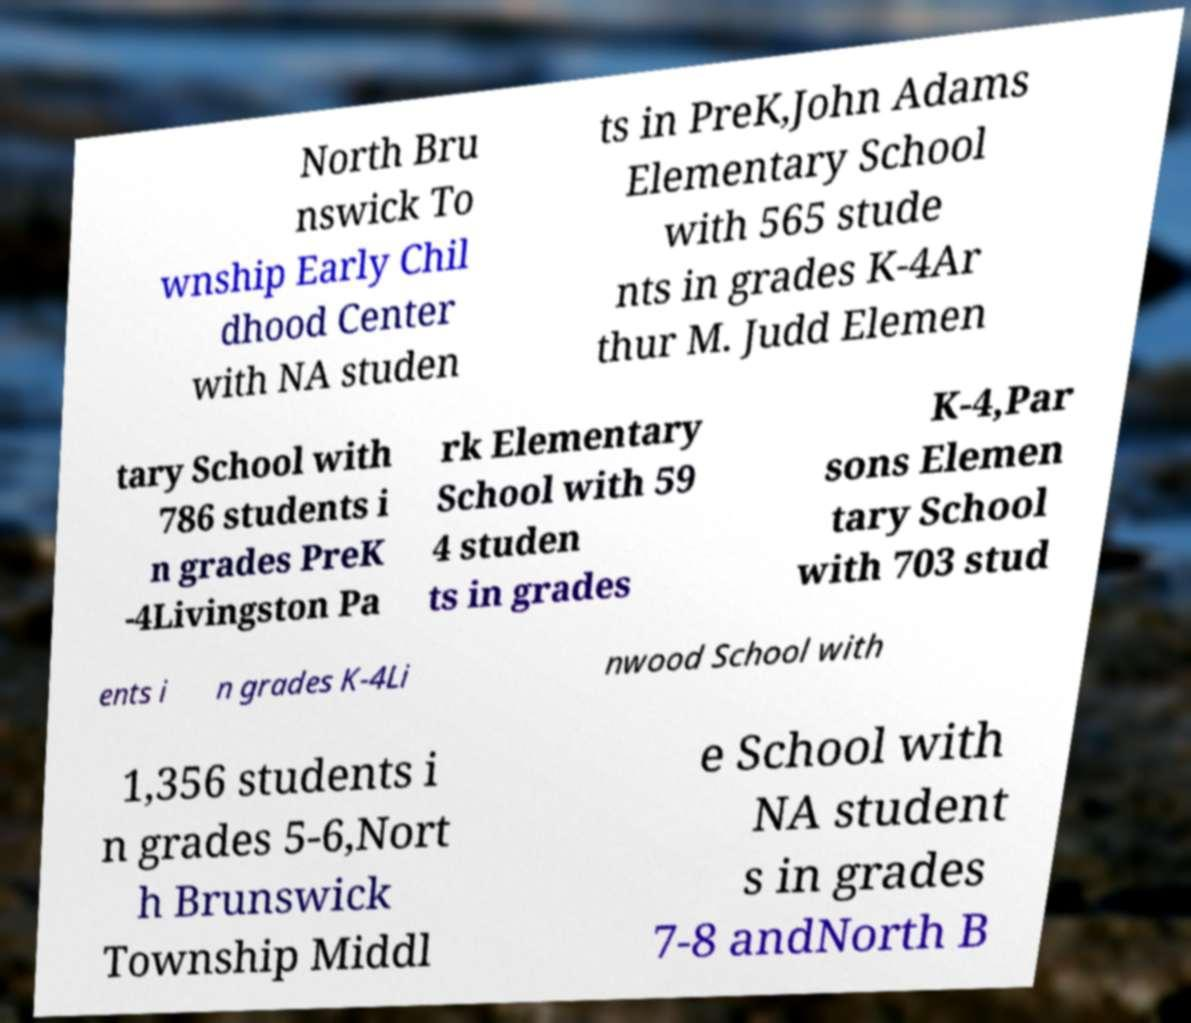Please read and relay the text visible in this image. What does it say? North Bru nswick To wnship Early Chil dhood Center with NA studen ts in PreK,John Adams Elementary School with 565 stude nts in grades K-4Ar thur M. Judd Elemen tary School with 786 students i n grades PreK -4Livingston Pa rk Elementary School with 59 4 studen ts in grades K-4,Par sons Elemen tary School with 703 stud ents i n grades K-4Li nwood School with 1,356 students i n grades 5-6,Nort h Brunswick Township Middl e School with NA student s in grades 7-8 andNorth B 